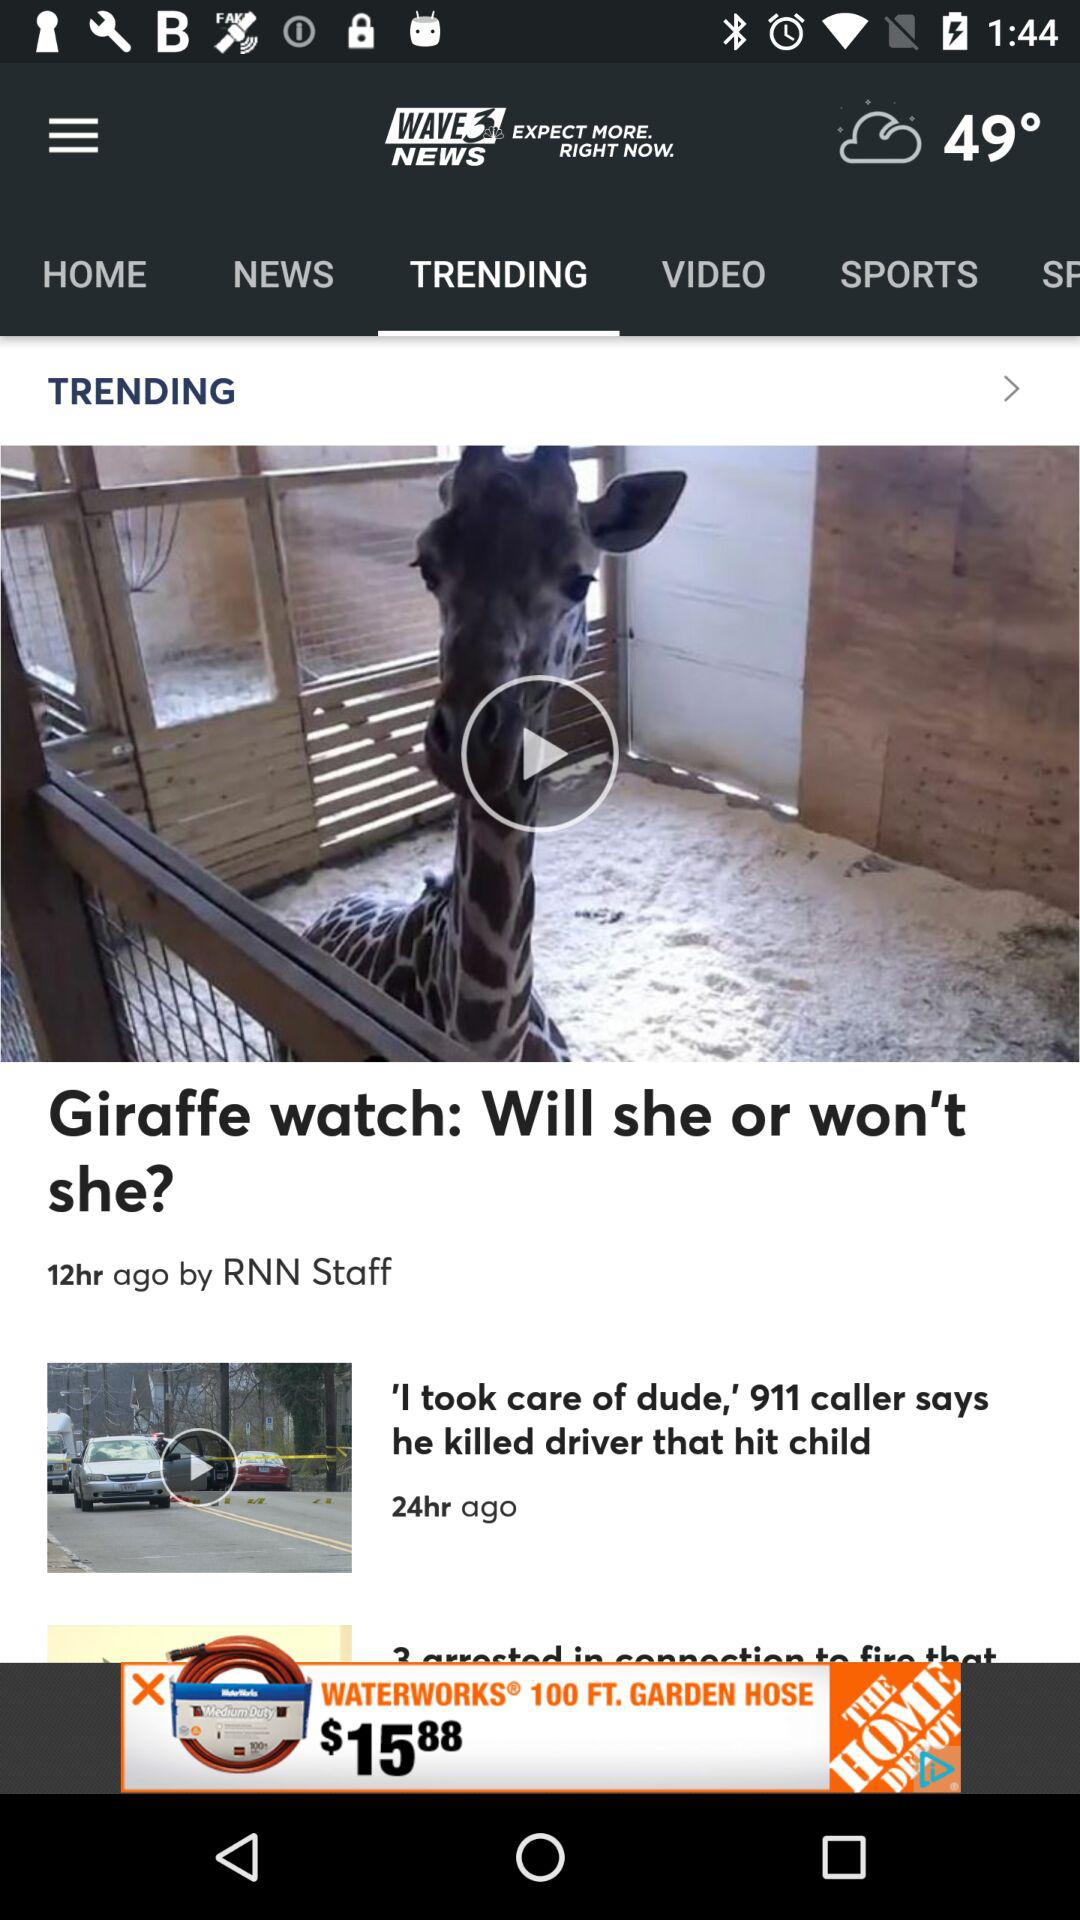How many stories are there in this article?
Answer the question using a single word or phrase. 3 